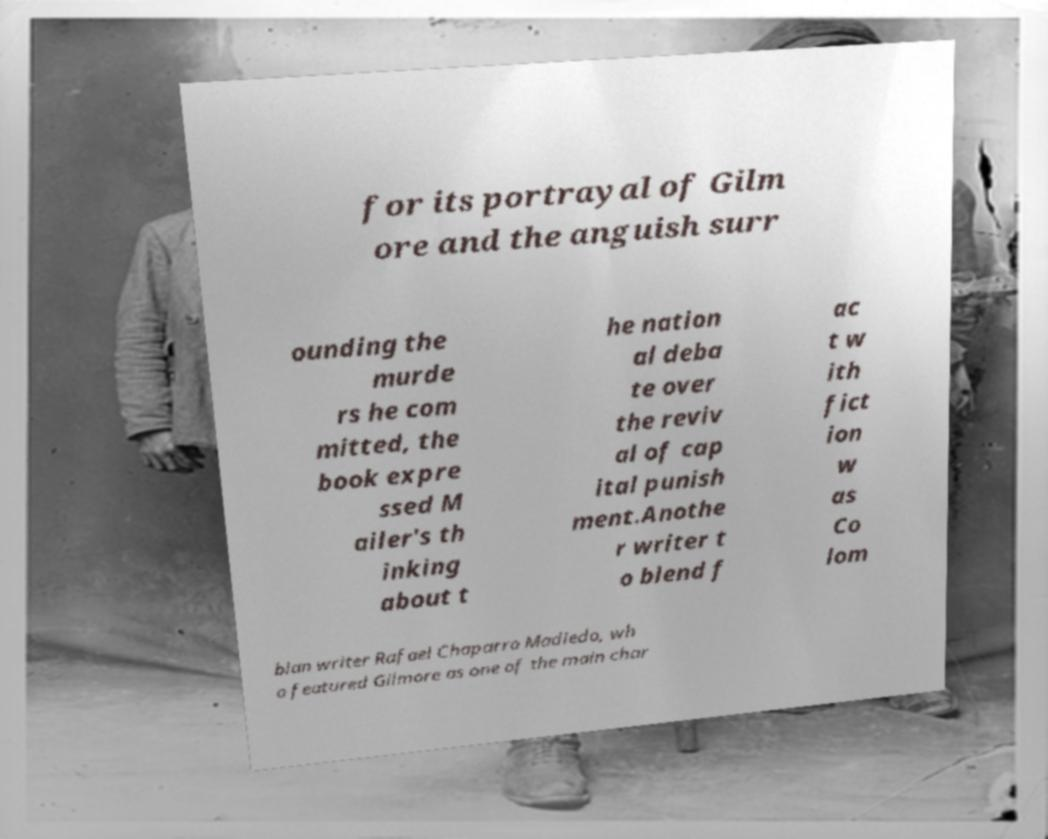For documentation purposes, I need the text within this image transcribed. Could you provide that? for its portrayal of Gilm ore and the anguish surr ounding the murde rs he com mitted, the book expre ssed M ailer's th inking about t he nation al deba te over the reviv al of cap ital punish ment.Anothe r writer t o blend f ac t w ith fict ion w as Co lom bian writer Rafael Chaparro Madiedo, wh o featured Gilmore as one of the main char 